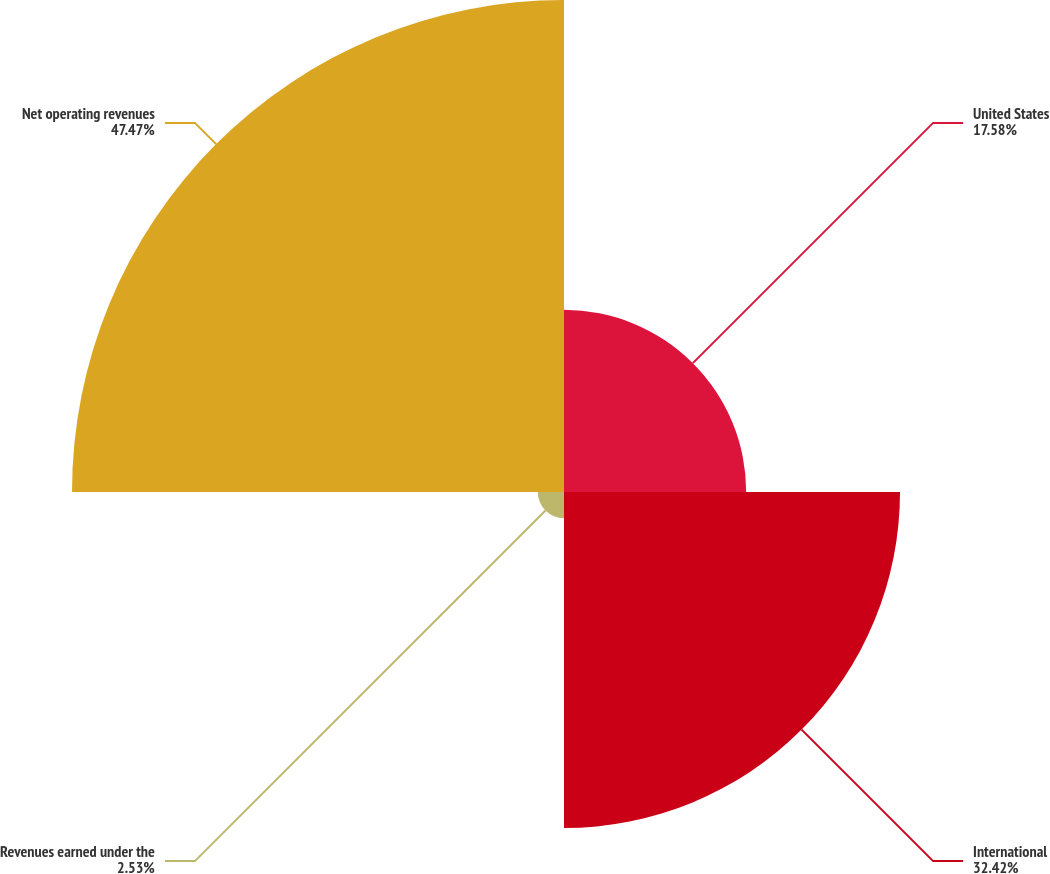Convert chart to OTSL. <chart><loc_0><loc_0><loc_500><loc_500><pie_chart><fcel>United States<fcel>International<fcel>Revenues earned under the<fcel>Net operating revenues<nl><fcel>17.58%<fcel>32.42%<fcel>2.53%<fcel>47.47%<nl></chart> 